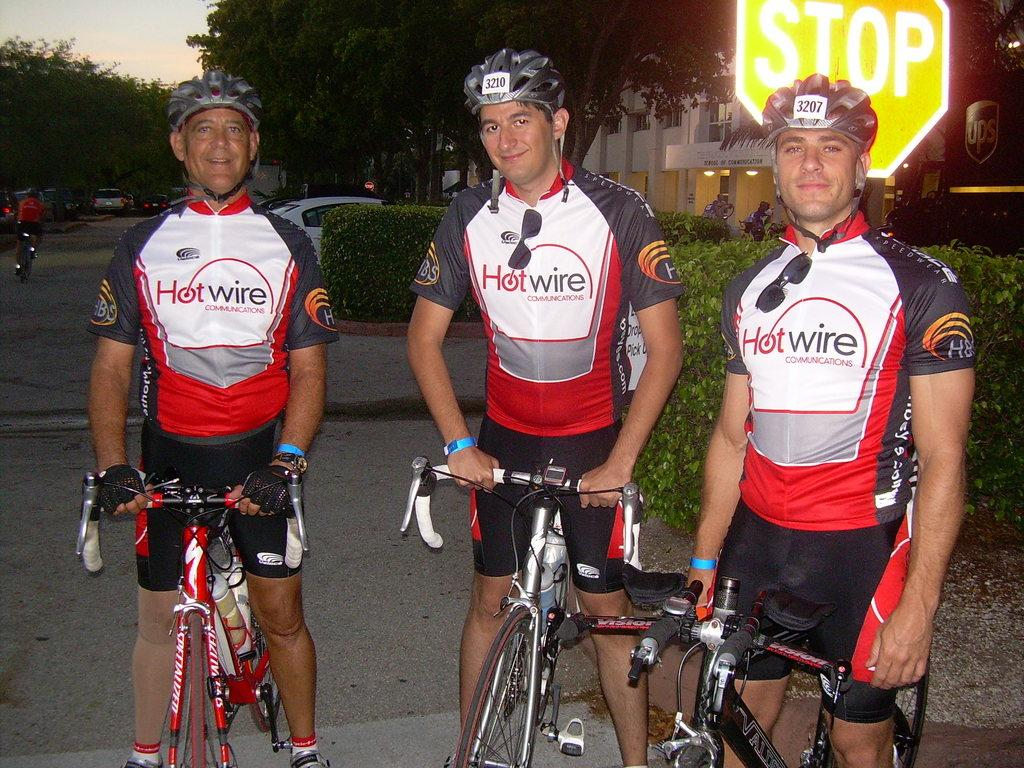How many people are in the image? There are three men in the image. What are the men doing in the image? The men are standing with their bicycles. What safety equipment are the men wearing? The men are wearing helmets. What type of cabbage is being used as a prop in the image? There is no cabbage present in the image. How does the air affect the men's bicycles in the image? The image does not provide information about the air or its effect on the bicycles. 